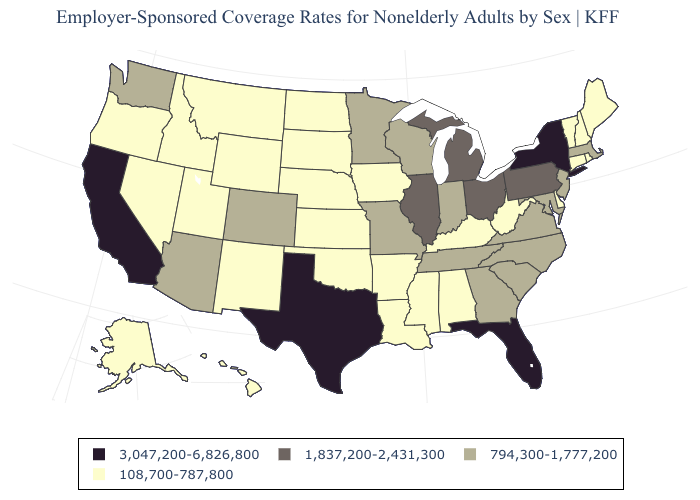Which states hav the highest value in the MidWest?
Write a very short answer. Illinois, Michigan, Ohio. Name the states that have a value in the range 3,047,200-6,826,800?
Give a very brief answer. California, Florida, New York, Texas. Is the legend a continuous bar?
Answer briefly. No. Does South Carolina have the lowest value in the USA?
Give a very brief answer. No. Which states have the highest value in the USA?
Answer briefly. California, Florida, New York, Texas. What is the highest value in states that border Tennessee?
Concise answer only. 794,300-1,777,200. Which states have the lowest value in the USA?
Keep it brief. Alabama, Alaska, Arkansas, Connecticut, Delaware, Hawaii, Idaho, Iowa, Kansas, Kentucky, Louisiana, Maine, Mississippi, Montana, Nebraska, Nevada, New Hampshire, New Mexico, North Dakota, Oklahoma, Oregon, Rhode Island, South Dakota, Utah, Vermont, West Virginia, Wyoming. What is the highest value in states that border Michigan?
Quick response, please. 1,837,200-2,431,300. Does Pennsylvania have a lower value than Texas?
Keep it brief. Yes. What is the value of West Virginia?
Give a very brief answer. 108,700-787,800. Which states have the highest value in the USA?
Keep it brief. California, Florida, New York, Texas. Does the first symbol in the legend represent the smallest category?
Concise answer only. No. What is the highest value in the South ?
Quick response, please. 3,047,200-6,826,800. Name the states that have a value in the range 108,700-787,800?
Answer briefly. Alabama, Alaska, Arkansas, Connecticut, Delaware, Hawaii, Idaho, Iowa, Kansas, Kentucky, Louisiana, Maine, Mississippi, Montana, Nebraska, Nevada, New Hampshire, New Mexico, North Dakota, Oklahoma, Oregon, Rhode Island, South Dakota, Utah, Vermont, West Virginia, Wyoming. 